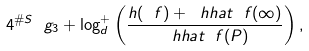<formula> <loc_0><loc_0><loc_500><loc_500>4 ^ { \# S } \ g _ { 3 } + \log ^ { + } _ { d } \left ( \frac { h ( \ f ) + \ h h a t _ { \ } f ( \infty ) } { \ h h a t _ { \ } f ( P ) } \right ) ,</formula> 